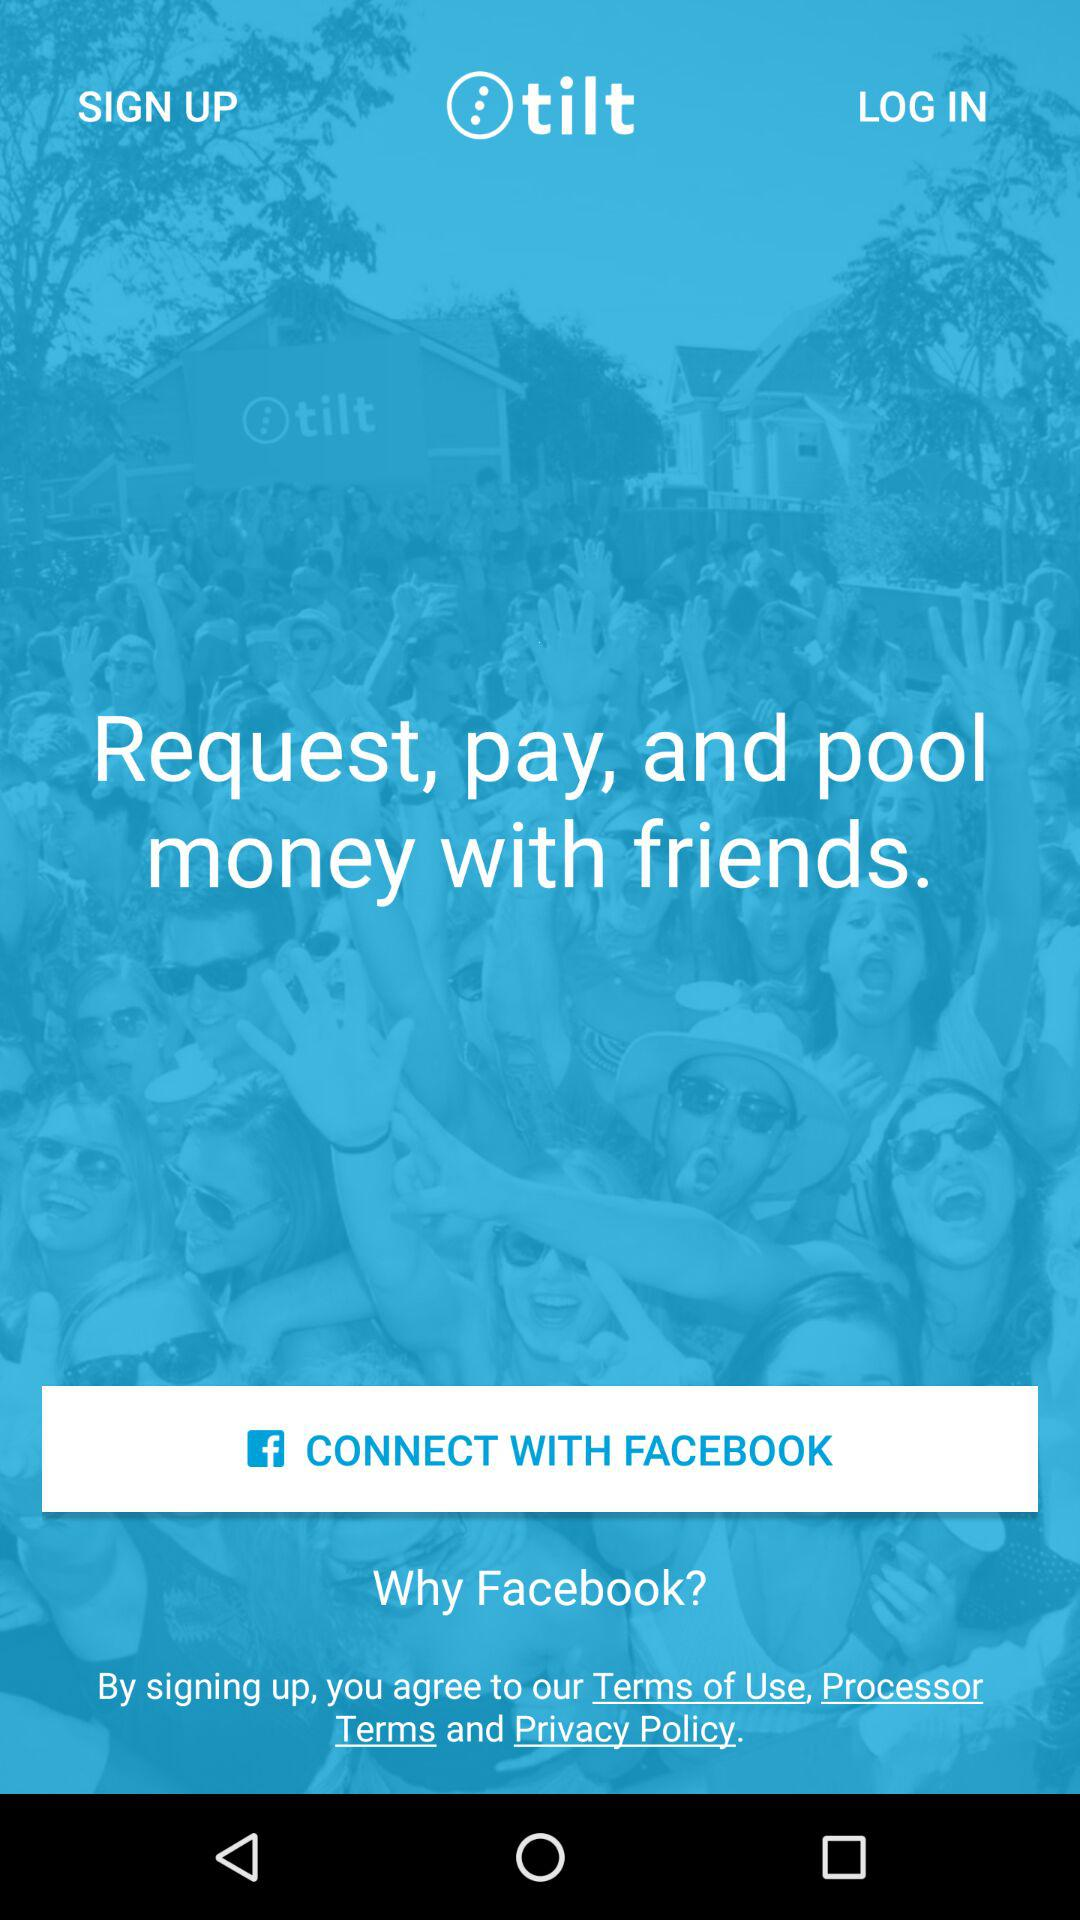Who is logging in?
When the provided information is insufficient, respond with <no answer>. <no answer> 